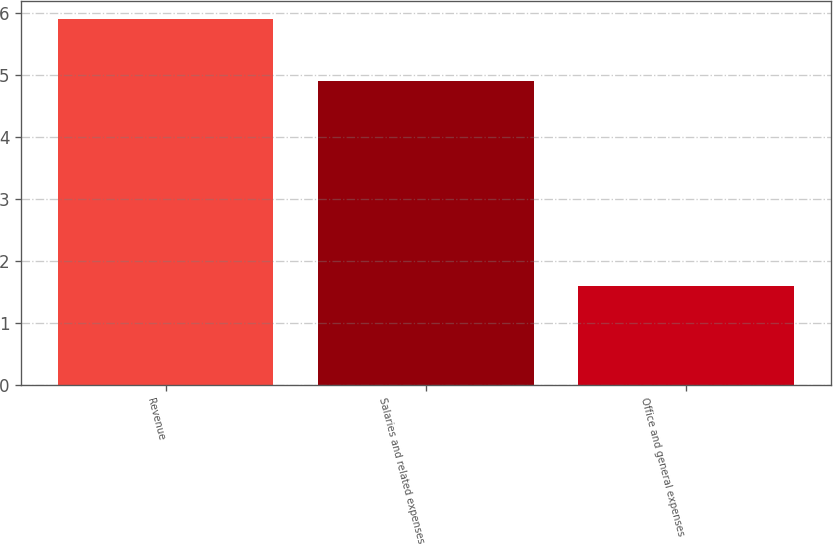Convert chart. <chart><loc_0><loc_0><loc_500><loc_500><bar_chart><fcel>Revenue<fcel>Salaries and related expenses<fcel>Office and general expenses<nl><fcel>5.9<fcel>4.9<fcel>1.6<nl></chart> 